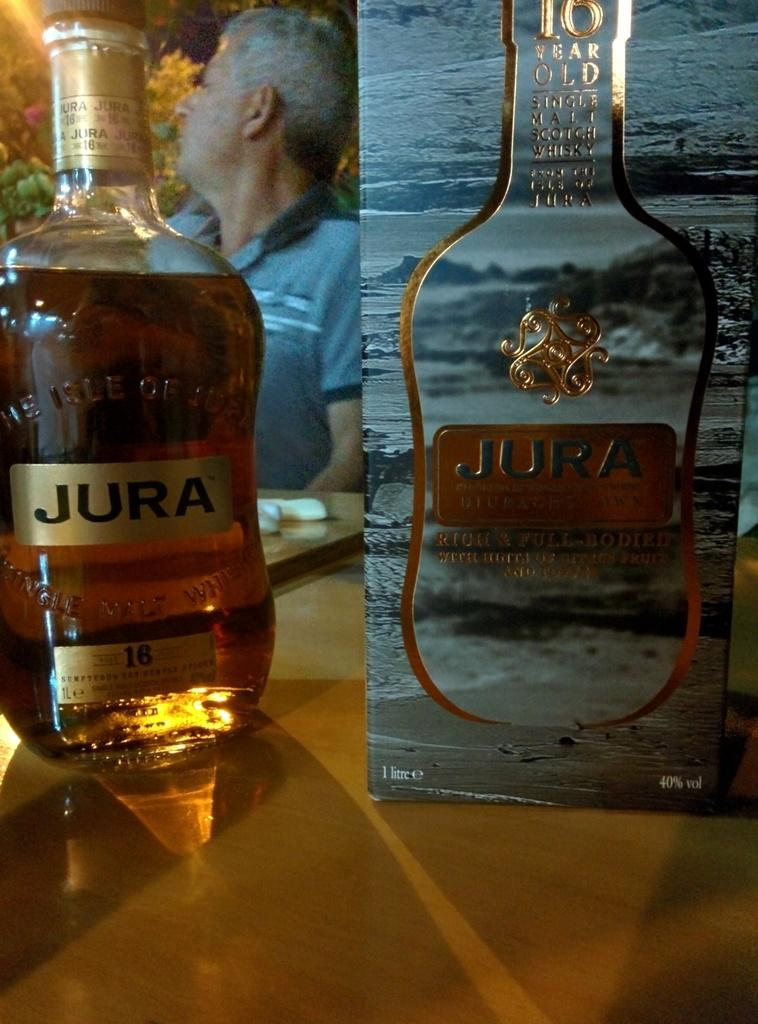<image>
Create a compact narrative representing the image presented. A bottle and box of Jura sits on a table. 